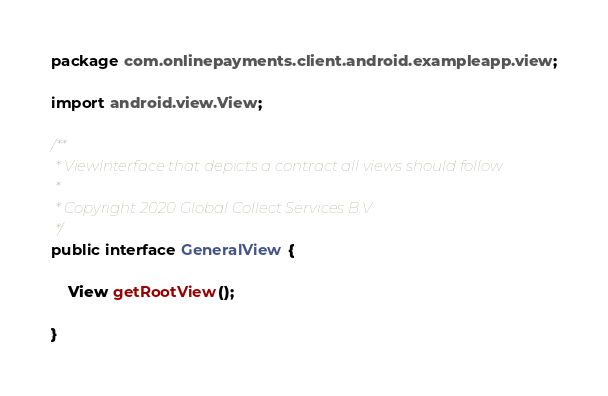Convert code to text. <code><loc_0><loc_0><loc_500><loc_500><_Java_>package com.onlinepayments.client.android.exampleapp.view;

import android.view.View;

/**
 * ViewInterface that depicts a contract all views should follow
 *
 * Copyright 2020 Global Collect Services B.V
 */
public interface GeneralView {

    View getRootView();

}
</code> 